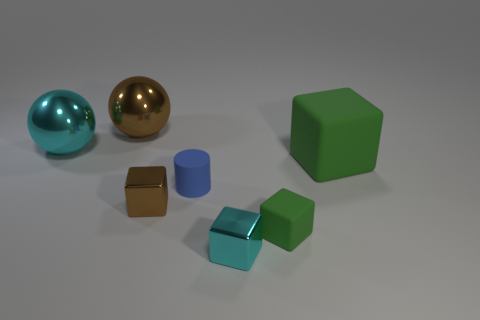Can you tell me about the colors used in the image? Certainly! The image presents a harmonious blend of colors dominated by cooler tones. A large cyan cube anchors the composition, complemented by a smaller cube of the same hue but with a metallic texture. Additionally, a serene blue color is seen on the cylindrical object. Warmth is introduced through the golden sphere and the smaller brown cubes, adding a pleasing contrast to the cooler colors. The green cube brings an additional natural touch to the scene. 